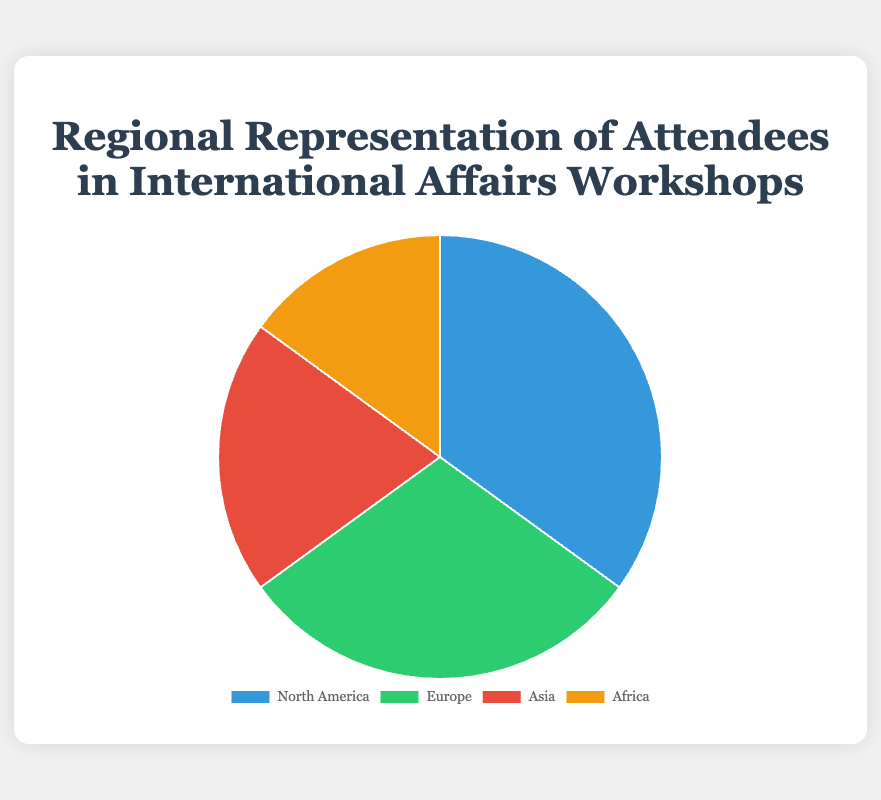What percentage of the attendees come from North America? To find the percentage of attendees from North America, refer to the segment labeled 'North America' in the chart. The provided data states that 35% of the attendees are from this region.
Answer: 35% Which region has the smallest representation in the workshop attendance? To determine the region with the smallest representation, look for the segment with the smallest size in the pie chart. From the data, Africa has the smallest percentage of attendees, which is 15%.
Answer: Africa What is the combined percentage of attendees from Europe and Asia? To find the combined percentage, add the individual percentages of attendees from Europe and Asia. Europe has 30% and Asia has 20%. The sum is 30% + 20% = 50%.
Answer: 50% Are there more attendees from North America or Europe? To compare the attendees from North America and Europe, look at the respective percentages. North America has 35%, while Europe has 30%. North America's percentage is greater.
Answer: North America What percentage of attendees come from outside North America and Europe? To determine the percentage from regions outside North America and Europe, add the percentages of attendees from Asia and Africa, as these are the regions not included. Asia has 20% and Africa has 15%. The sum is 20% + 15% = 35%.
Answer: 35% Which region has the second highest representation of attendees? To find the second highest representation, identify the region with the second largest segment in the pie chart. The data indicates that North America has the highest at 35%, followed by Europe at 30%.
Answer: Europe What is the percentage difference between the attendees from Asia and Africa? To find the percentage difference, subtract the smaller percentage (Africa's 15%) from the larger percentage (Asia's 20%). The difference is 20% - 15% = 5%.
Answer: 5% If the total number of attendees is 200, how many attendees are from Europe? To find the number of attendees from Europe, calculate 30% of 200. The number is calculated as 200 * 0.30 = 60.
Answer: 60 By how much does the percentage of North American attendees exceed the percentage of Asian attendees? Calculate the difference between the percentages of North American and Asian attendees. North America has 35%, and Asia has 20%. The difference is 35% - 20% = 15%.
Answer: 15% What color represents the attendees from Asia in the pie chart? Identify the color shown in the pie chart segment labeled 'Asia'. According to the data, Asia is represented by the color red.
Answer: Red 